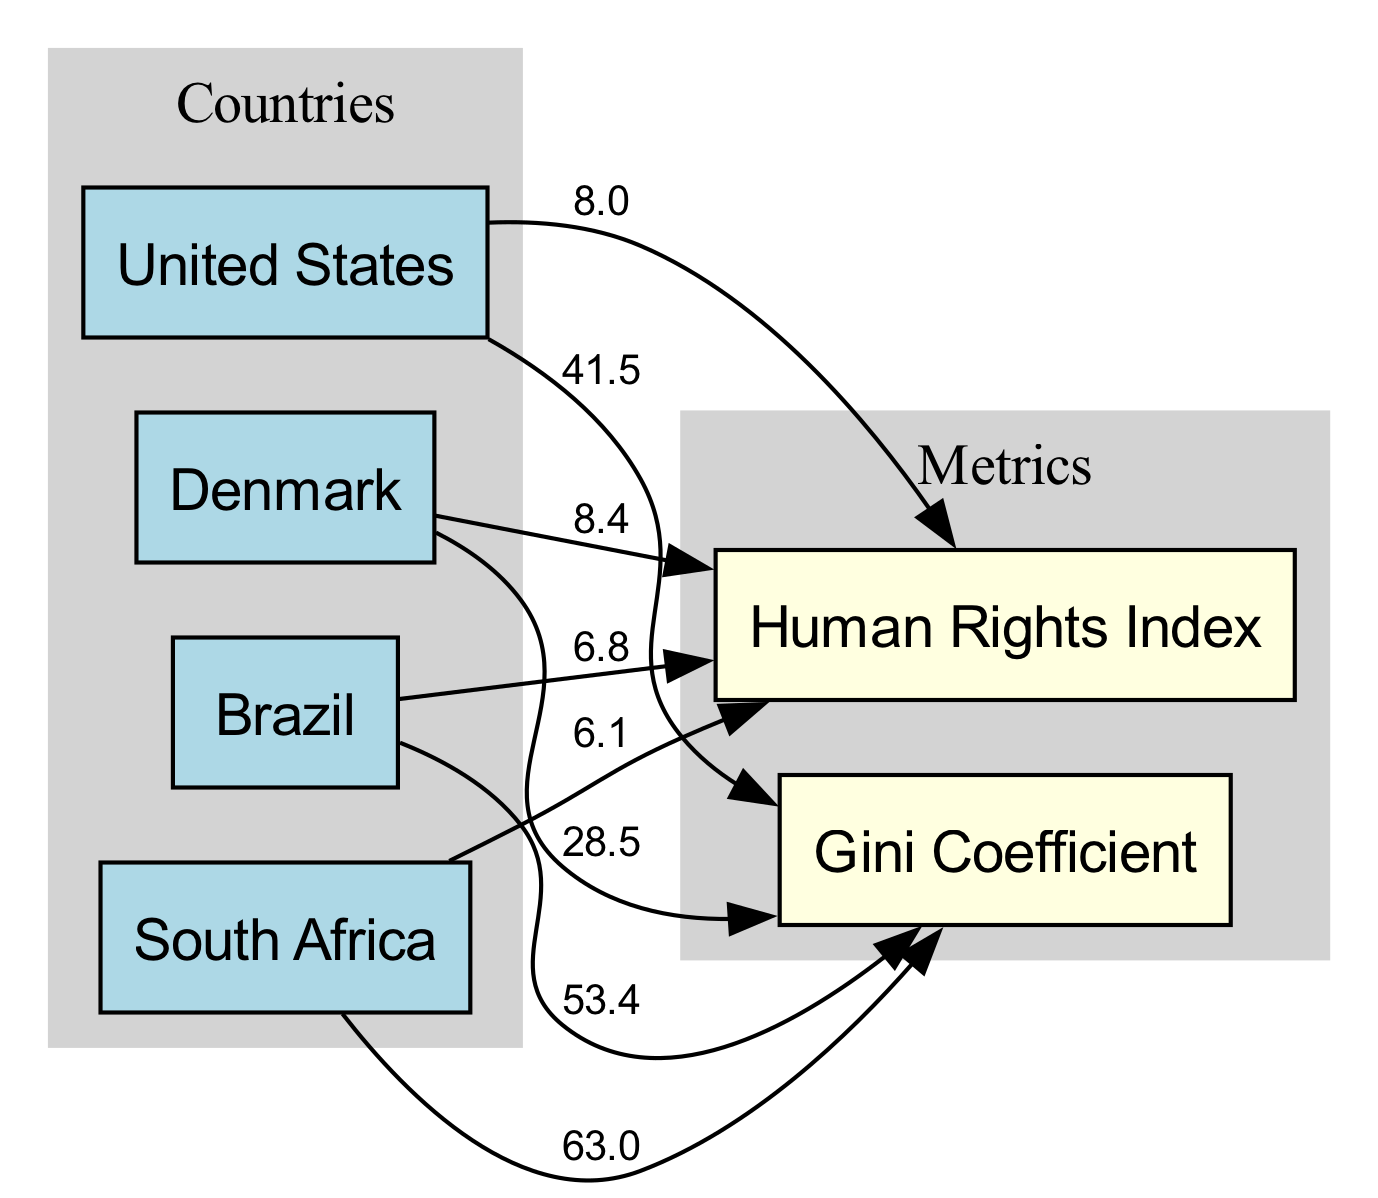What is the Gini Coefficient for Denmark? The diagram displays Denmark's Gini Coefficient directly connected with a label showing the value. I find the label next to Denmark pointing to the Gini Coefficient, which states that it is 28.5.
Answer: 28.5 What is the Human Rights Index of Brazil? The diagram shows a direct connection from Brazil to the Human Rights Index, which is associated with the label. On checking this edge, I find that the label associated with Brazil's Human Rights Index reads 6.8.
Answer: 6.8 Which country has the highest Gini Coefficient? To determine which country has the highest Gini Coefficient, I examine the Gini Coefficient values for all the countries connected to this metric. South Africa has the highest value of 63.0, hence it is identified as having the highest Gini Coefficient.
Answer: South Africa What is the relationship between the Gini Coefficient and the Human Rights Index for the United States? The diagram illustrates both the Gini Coefficient and the Human Rights Index for the United States. I see that the Gini Coefficient is 41.5 while the Human Rights Index is 8.0. This shows that as the Gini Coefficient increases, the Human Rights Index is lower, indicating a potential inverse relationship.
Answer: Gini Coefficient: 41.5, Human Rights Index: 8.0 How many countries are represented in the diagram? The diagram contains nodes that represent specific countries. By counting the nodes designated as countries, I find that there are four countries present in the diagram: United States, Denmark, Brazil, and South Africa.
Answer: 4 Which country shows the strongest Human Rights Index? Looking closely at the edges linking countries to the Human Rights Index, I identify the values for each country. Denmark is shown to have the highest Human Rights Index value of 8.4, making it the strongest in this context.
Answer: Denmark What is the Gini Coefficient for South Africa? The diagram directly connects South Africa to the Gini Coefficient and includes a label specifically for this value. Upon checking, I see that the Gini Coefficient for South Africa is labeled as 63.0.
Answer: 63.0 Is there a correlation between Gini Coefficient and Human Rights Index in the diagram? To assess the correlation, I compare the Gini Coefficient values with the corresponding Human Rights Index values for all countries depicted. I can see that countries with higher Gini Coefficient values generally tend to have lower Human Rights Index scores, indicating a potential negative correlation.
Answer: Yes, negative correlation 